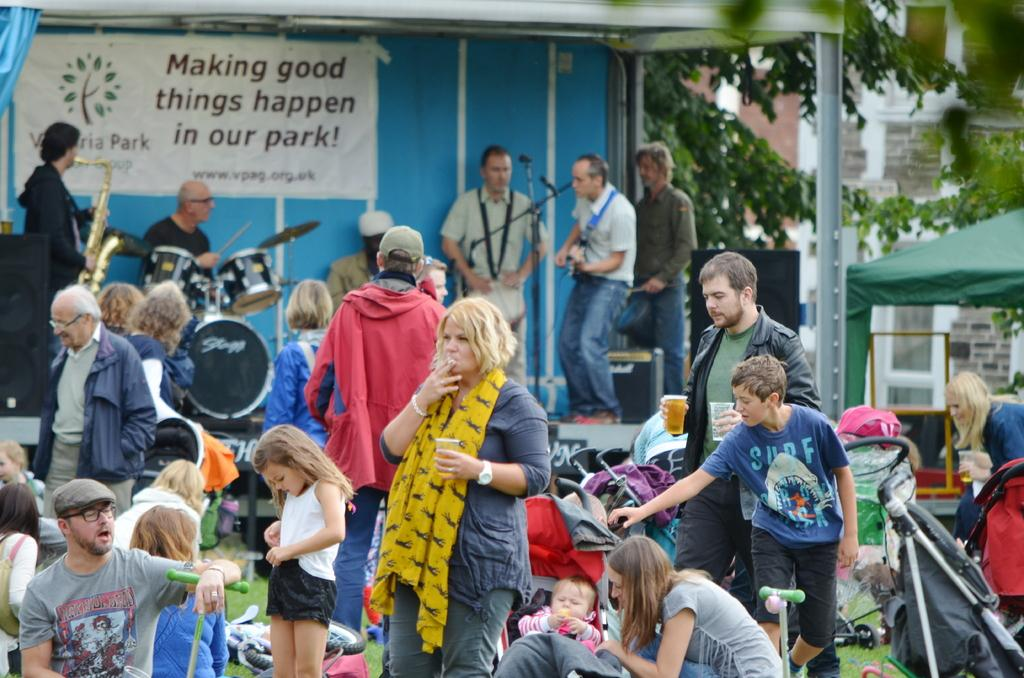How many people are in the group that is visible in the image? There is a group of people in the image, but the exact number is not specified. What type of objects are present in the image that are used for making music? Musical instruments are present in the image. What are the microphones used for in the image? Microphones (mics) are visible in the image, and they are likely used for amplifying sound during a performance. What can be seen on the banner in the image? The content of the banner is not specified in the facts. What type of clothing can be seen in the image? Clothes are present in the image, but the specific styles or colors are not mentioned. What is the purpose of the tent in the image? The purpose of the tent is not specified in the facts. What are the speakers used for in the image? Speakers are present in the image, and they are likely used for amplifying sound during a performance. What are the unspecified objects in the image? The facts do not provide any information about the unspecified objects in the image. What can be seen in the background of the image? There is a building and trees in the background of the image. Where is the pest hiding in the image? There is no mention of a pest in the image, so it cannot be determined where it might be hiding. What part of the brain is visible in the image? There is no brain present in the image, so it cannot be determined which part might be visible. What type of kettle is being used to make tea in the image? There is no kettle present in the image, so it cannot be determined if any tea is being made. 